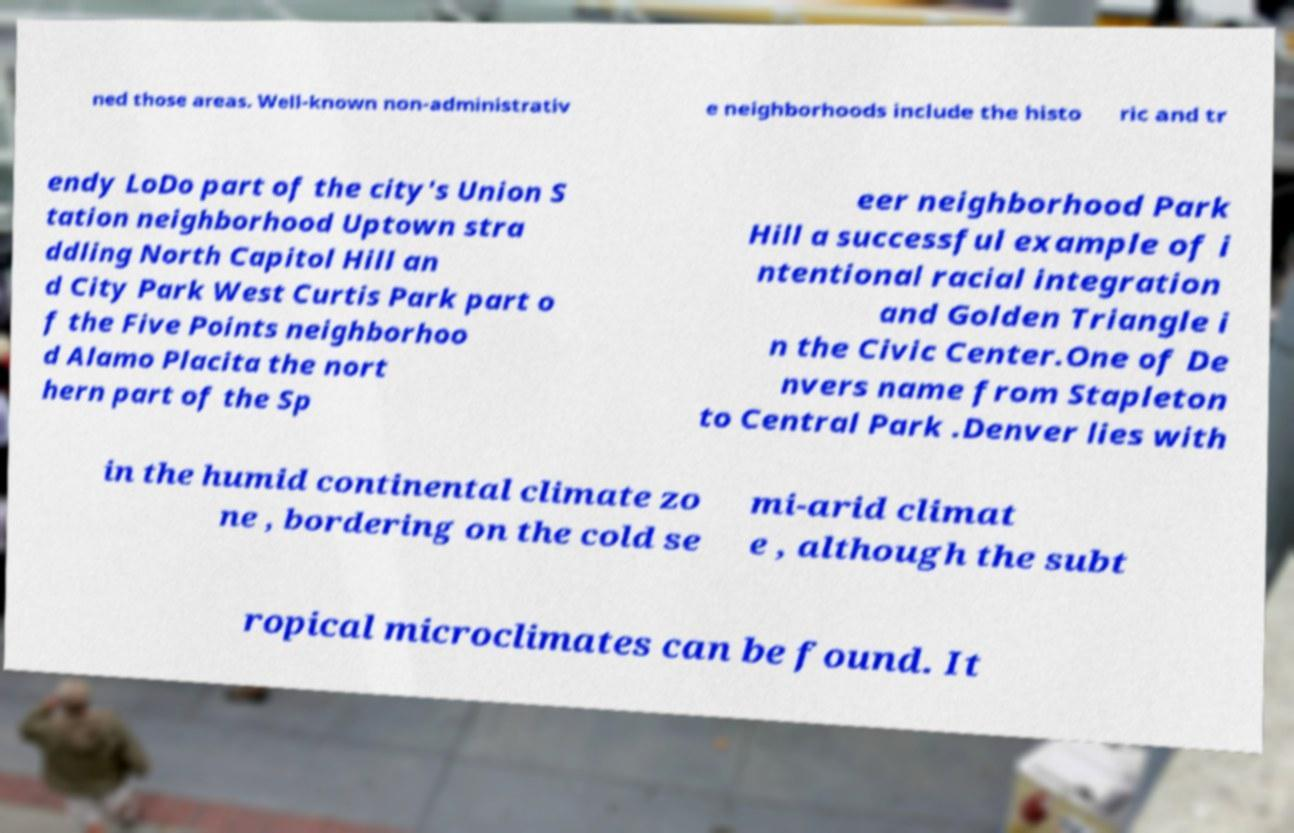Can you read and provide the text displayed in the image?This photo seems to have some interesting text. Can you extract and type it out for me? ned those areas. Well-known non-administrativ e neighborhoods include the histo ric and tr endy LoDo part of the city's Union S tation neighborhood Uptown stra ddling North Capitol Hill an d City Park West Curtis Park part o f the Five Points neighborhoo d Alamo Placita the nort hern part of the Sp eer neighborhood Park Hill a successful example of i ntentional racial integration and Golden Triangle i n the Civic Center.One of De nvers name from Stapleton to Central Park .Denver lies with in the humid continental climate zo ne , bordering on the cold se mi-arid climat e , although the subt ropical microclimates can be found. It 